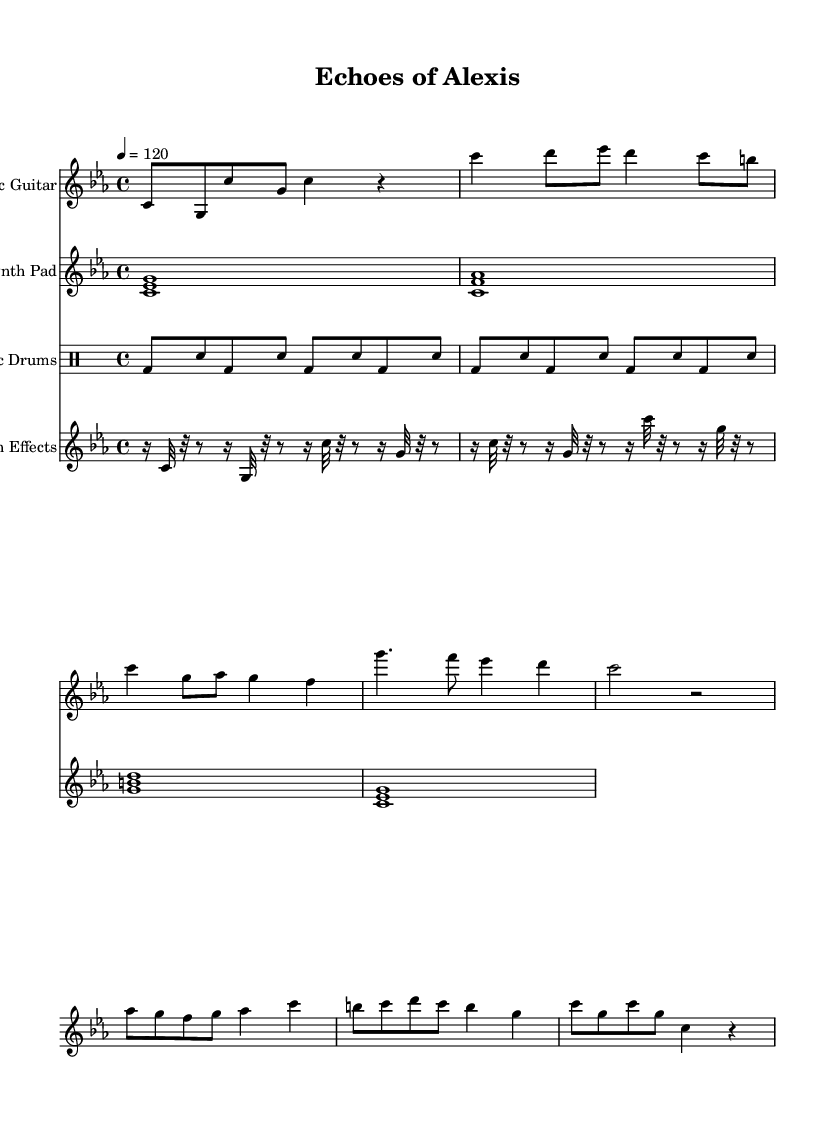What is the key signature of this music? The key signature is C minor, which includes three flats (B flat, E flat, and A flat). This can be seen at the beginning of the sheet music where the flats are placed on the staff.
Answer: C minor What is the time signature of this music? The time signature is 4/4, indicating that there are four beats in each measure and the quarter note gets the beat. This is explicitly specified in the score after the key signature.
Answer: 4/4 What is the tempo marking in the score? The tempo marking is specified at the beginning as "4 = 120," meaning there are 120 beats per minute, which indicates the speed of the music.
Answer: 120 How many different instruments are featured in this score? The score includes four distinct instruments: Acoustic Guitar, Synth Pad, Electronic Drums, and Glitch Effects. Each of these is written on a separate staff, allowing them to be read and performed together.
Answer: Four Which section of the music uses glitch effects? The Glitch Effects are utilized in the section labeled "Glitch Effects," where the notes are primarily 32nd and 16th notes, creating a stutter-like sound, characteristic of electronic music.
Answer: Glitch Effects What type of drum pattern is used in this score? The drum pattern consists of a kick drum (bd) and snare (sn) alternating in a straightforward rhythm throughout the sections. This is typical of many electronic genres, emphasizing the beat.
Answer: Alternating kick and snare What is the primary harmonic structure suggested by the Synth Pad? The Synth Pad shows chords that create a lush sound. The first chord is a C minor and the following chords suggest a progression, typical for creating atmosphere in electronic music.
Answer: C minor, F major, G major 